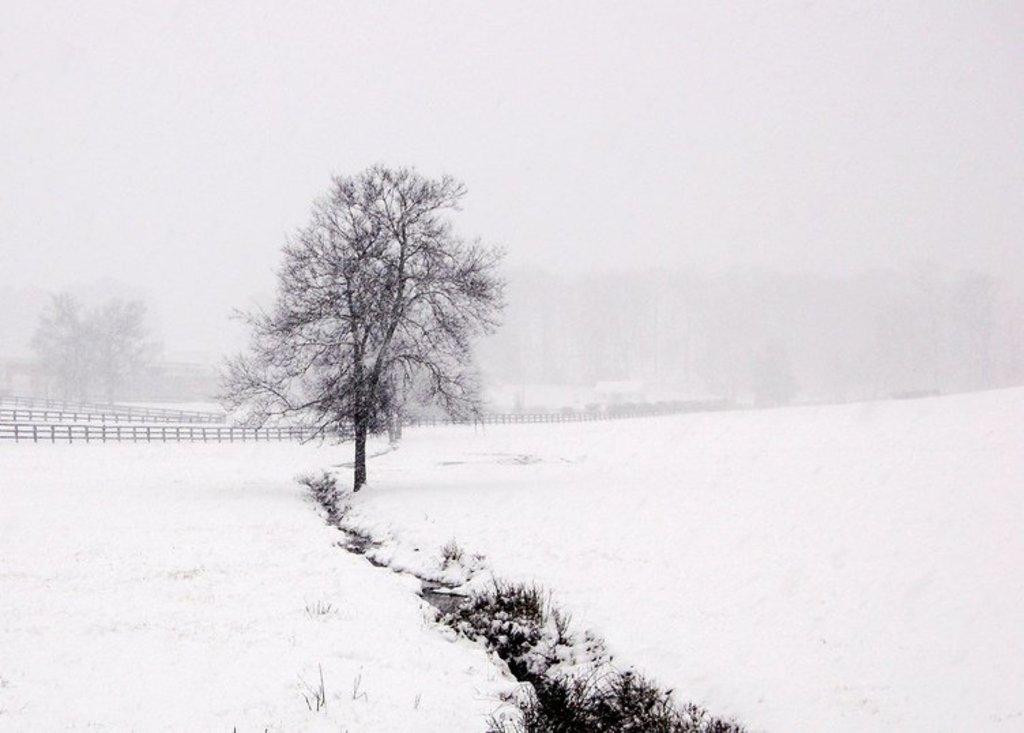What type of vegetation is present in the image? There is grass and trees in the image. What type of barrier is visible in the image? There is a fence in the image. What weather condition is depicted in the image? There is snow and fog in the image. What part of the natural environment is visible in the image? The sky is visible in the image. Based on the presence of sunlight, when might the image have been taken? The image was likely taken during the day. What type of oven is visible in the image? There is no oven present in the image. How many mittens can be seen in the image? There are no mittens present in the image. 